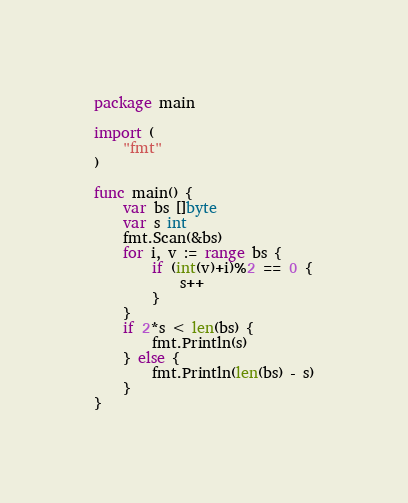Convert code to text. <code><loc_0><loc_0><loc_500><loc_500><_Go_>package main

import (
	"fmt"
)

func main() {
	var bs []byte
	var s int
	fmt.Scan(&bs)
	for i, v := range bs {
		if (int(v)+i)%2 == 0 {
			s++
		}
	}
	if 2*s < len(bs) {
		fmt.Println(s)
	} else {
		fmt.Println(len(bs) - s)
	}
}
</code> 